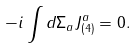Convert formula to latex. <formula><loc_0><loc_0><loc_500><loc_500>- i \int d \Sigma _ { a } J _ { ( 4 ) } ^ { a } = 0 .</formula> 